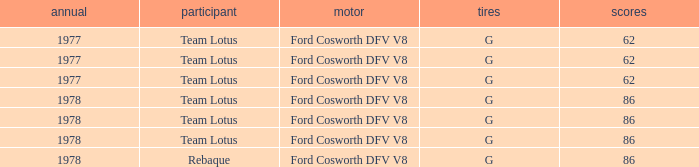What is the Focus that has a Year bigger than 1977? 86, 86, 86, 86. 